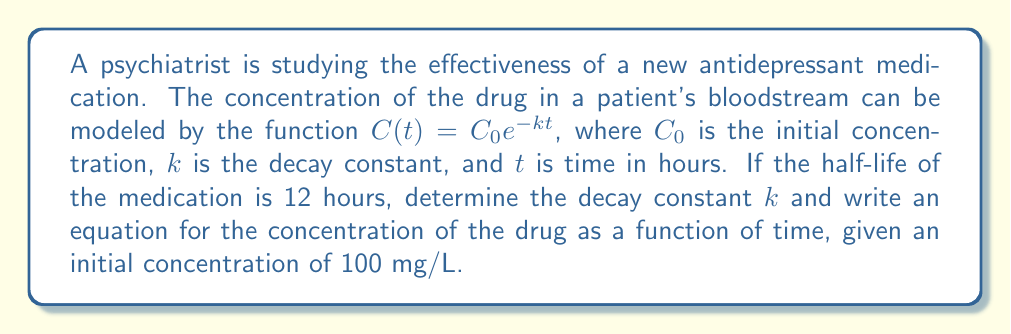Give your solution to this math problem. To solve this problem, we'll follow these steps:

1) The half-life is the time it takes for the concentration to decrease to half of its initial value. We know this occurs at t = 12 hours.

2) We can express this mathematically as:

   $$C(12) = \frac{1}{2}C_0$$

3) Substituting this into our general equation:

   $$\frac{1}{2}C_0 = C_0e^{-k(12)}$$

4) We can simplify this by dividing both sides by $C_0$:

   $$\frac{1}{2} = e^{-12k}$$

5) Taking the natural log of both sides:

   $$\ln(\frac{1}{2}) = -12k$$

6) Solving for k:

   $$k = -\frac{\ln(\frac{1}{2})}{12} = \frac{\ln(2)}{12} \approx 0.0578$$

7) Now that we have k, we can write the full equation. Remember, $C_0 = 100$ mg/L:

   $$C(t) = 100e^{-0.0578t}$$

This equation models the concentration of the drug in mg/L as a function of time in hours.
Answer: The decay constant $k \approx 0.0578$ hour$^{-1}$, and the equation for the concentration of the drug as a function of time is $C(t) = 100e^{-0.0578t}$ mg/L, where $t$ is in hours. 